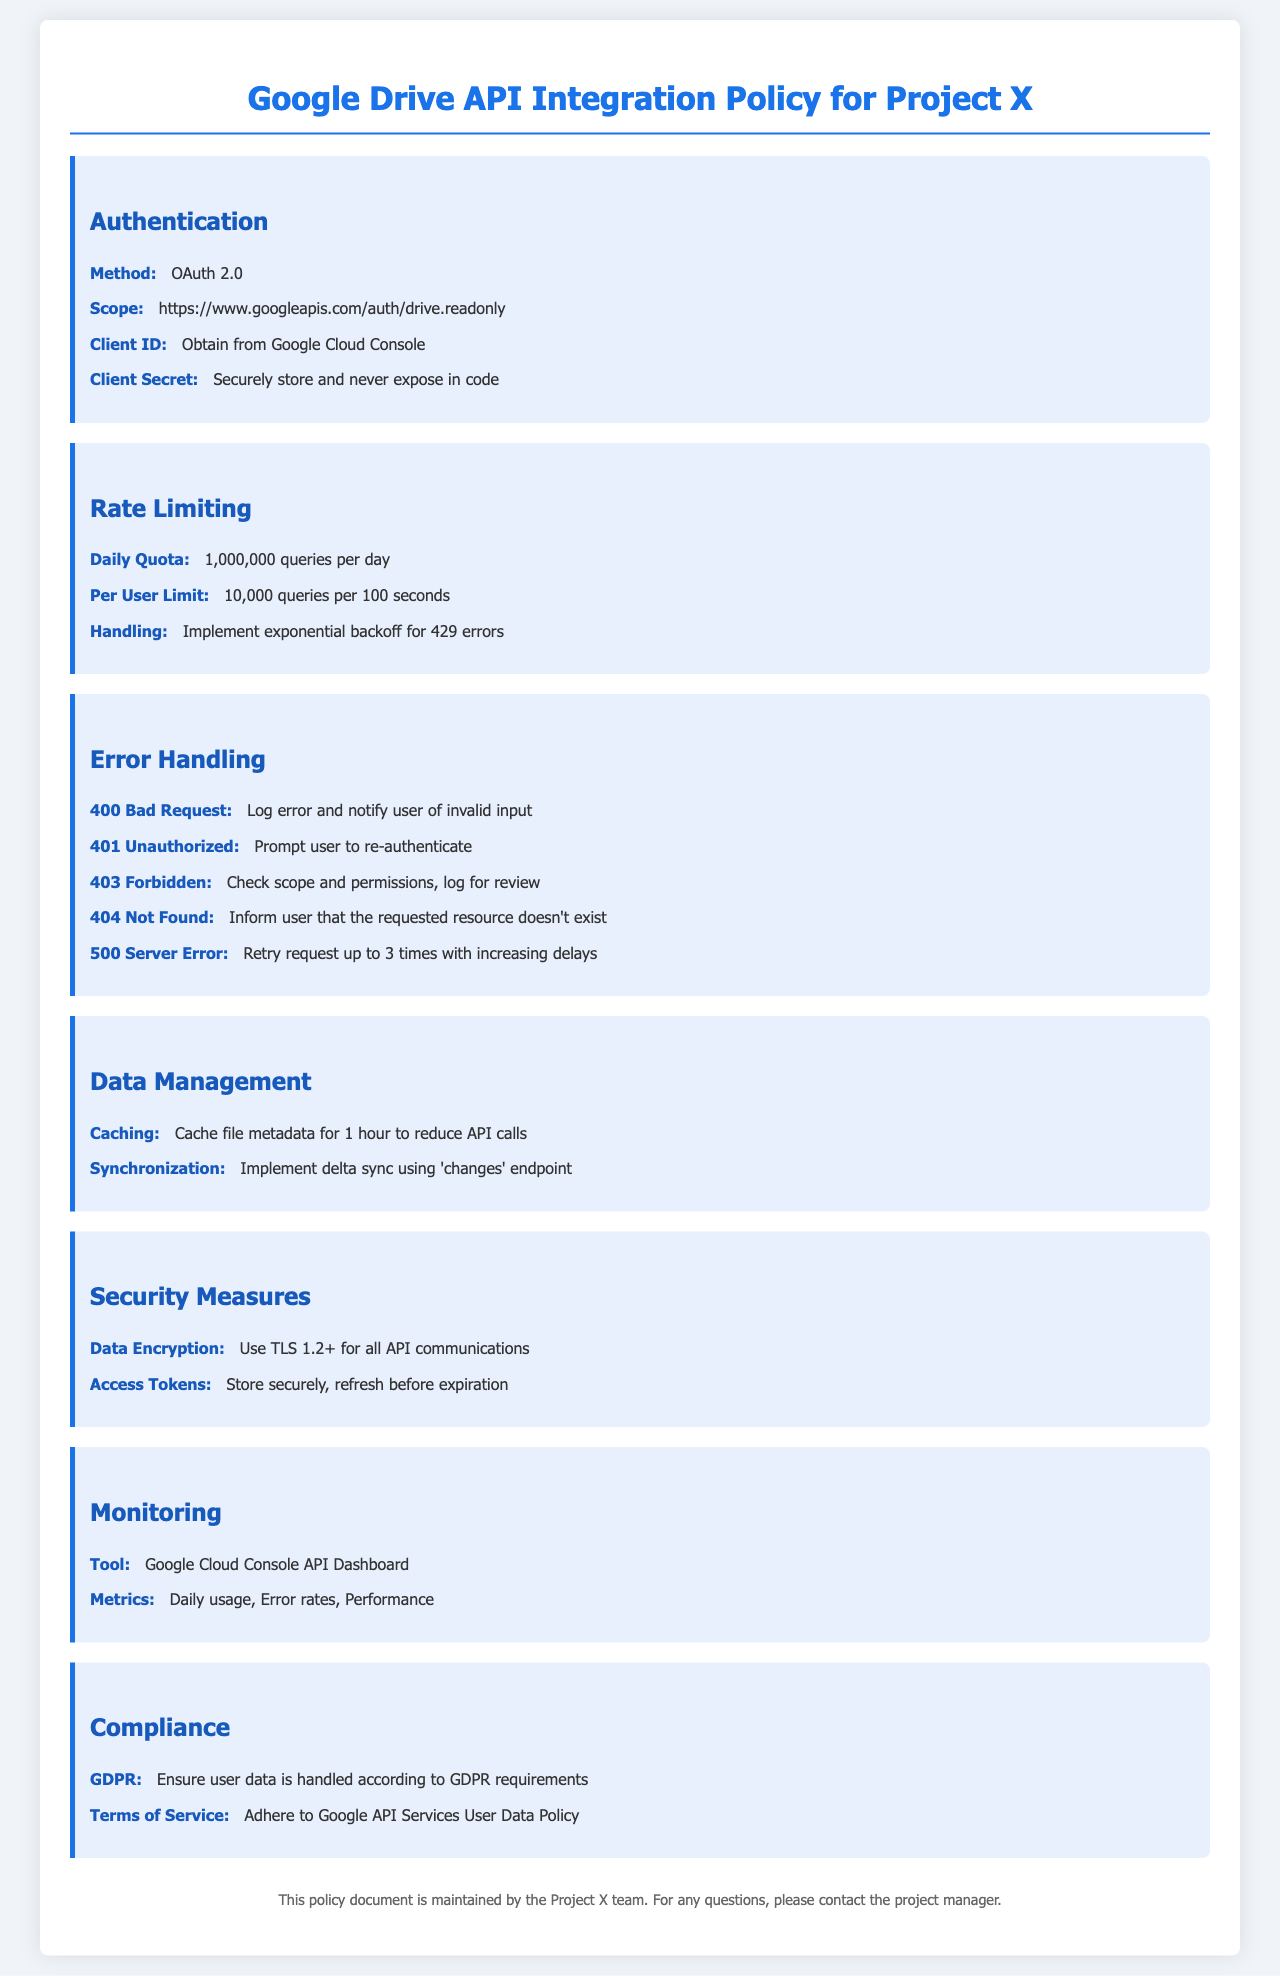What is the authentication method? The authentication method is specified in the policy under the Authentication section.
Answer: OAuth 2.0 What is the daily query limit? The daily query limit can be found in the Rate Limiting section.
Answer: 1,000,000 queries per day What should be done for a 401 Unauthorized error? The response to this error is mentioned under the Error Handling section.
Answer: Prompt user to re-authenticate What is the scope for the Google Drive API? The scope is listed in the Authentication section of the document.
Answer: https://www.googleapis.com/auth/drive.readonly How many queries are allowed per user in 100 seconds? This limit is provided in the Rate Limiting section.
Answer: 10,000 queries per 100 seconds What is the recommended action for a 404 Not Found error? The action for this error is described under the Error Handling section.
Answer: Inform user that the requested resource doesn't exist What is the purpose of caching file metadata? The reason for caching is outlined in the Data Management section.
Answer: To reduce API calls What security protocol should be used for API communications? The required security protocol is mentioned in the Security Measures section.
Answer: TLS 1.2+ Which tool is used for monitoring API usage? The tool is indicated in the Monitoring section.
Answer: Google Cloud Console API Dashboard 